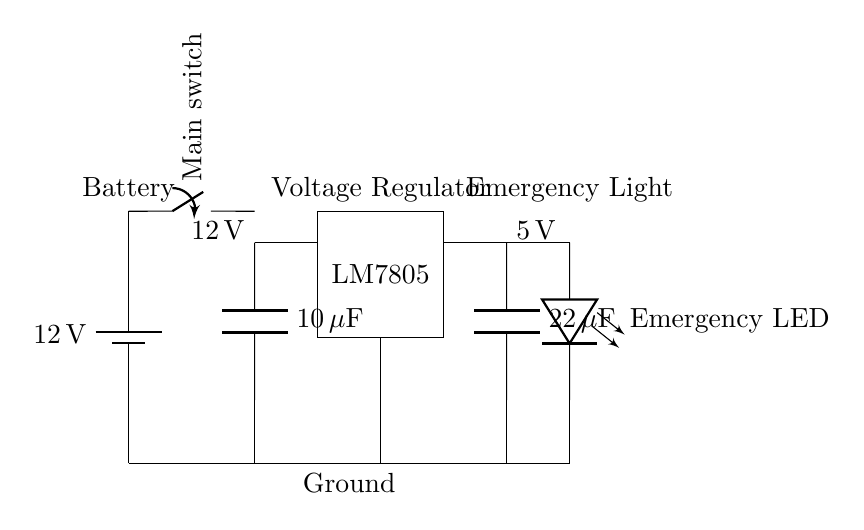What is the main function of the LM7805 in this circuit? The LM7805 is a voltage regulator that steps down the input voltage of 12 volts to a stable output voltage of 5 volts, which is suitable for powering components like LEDs.
Answer: Voltage regulator What is the value of the input capacitor? The circuit diagram shows a capacitor labeled as 10 microfarads, which is designed to stabilize the voltage input to the regulator and prevent fluctuations.
Answer: 10 microfarads What voltage does the emergency light operate at? The circuit indicates that the output voltage after the LM7805 voltage regulator is 5 volts, which powers the emergency LED light in the circuit.
Answer: 5 volts Why is the output capacitor used in this circuit? The output capacitor, which is 22 microfarads, helps filter and smooth out the output voltage from the regulator, ensuring stable power supply to the load.
Answer: 22 microfarads What type of load is connected to the output of the regulator? The diagram features a LED symbol, which signifies that the load connected to the output of the voltage regulator is an emergency light, typically an LED type.
Answer: Emergency LED What is the input voltage supplied by the battery? The diagram clearly labels the battery providing 12 volts, which is the initial voltage before regulation.
Answer: 12 volts 